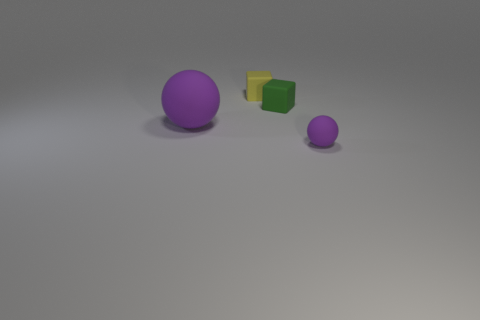Is there a big rubber thing of the same color as the small sphere?
Keep it short and to the point. Yes. There is a purple rubber thing that is the same size as the green cube; what shape is it?
Your response must be concise. Sphere. What number of purple things are either big balls or cylinders?
Ensure brevity in your answer.  1. How many yellow rubber objects have the same size as the green thing?
Ensure brevity in your answer.  1. There is a large rubber object that is the same color as the tiny matte sphere; what shape is it?
Give a very brief answer. Sphere. What number of objects are green metal spheres or matte objects that are to the left of the green matte object?
Make the answer very short. 2. There is a purple ball on the left side of the green cube; does it have the same size as the ball on the right side of the small green object?
Offer a very short reply. No. How many other rubber things are the same shape as the green thing?
Offer a terse response. 1. There is a yellow thing that is made of the same material as the green cube; what shape is it?
Your answer should be very brief. Cube. Do the green rubber cube and the matte object right of the small green thing have the same size?
Your answer should be compact. Yes. 